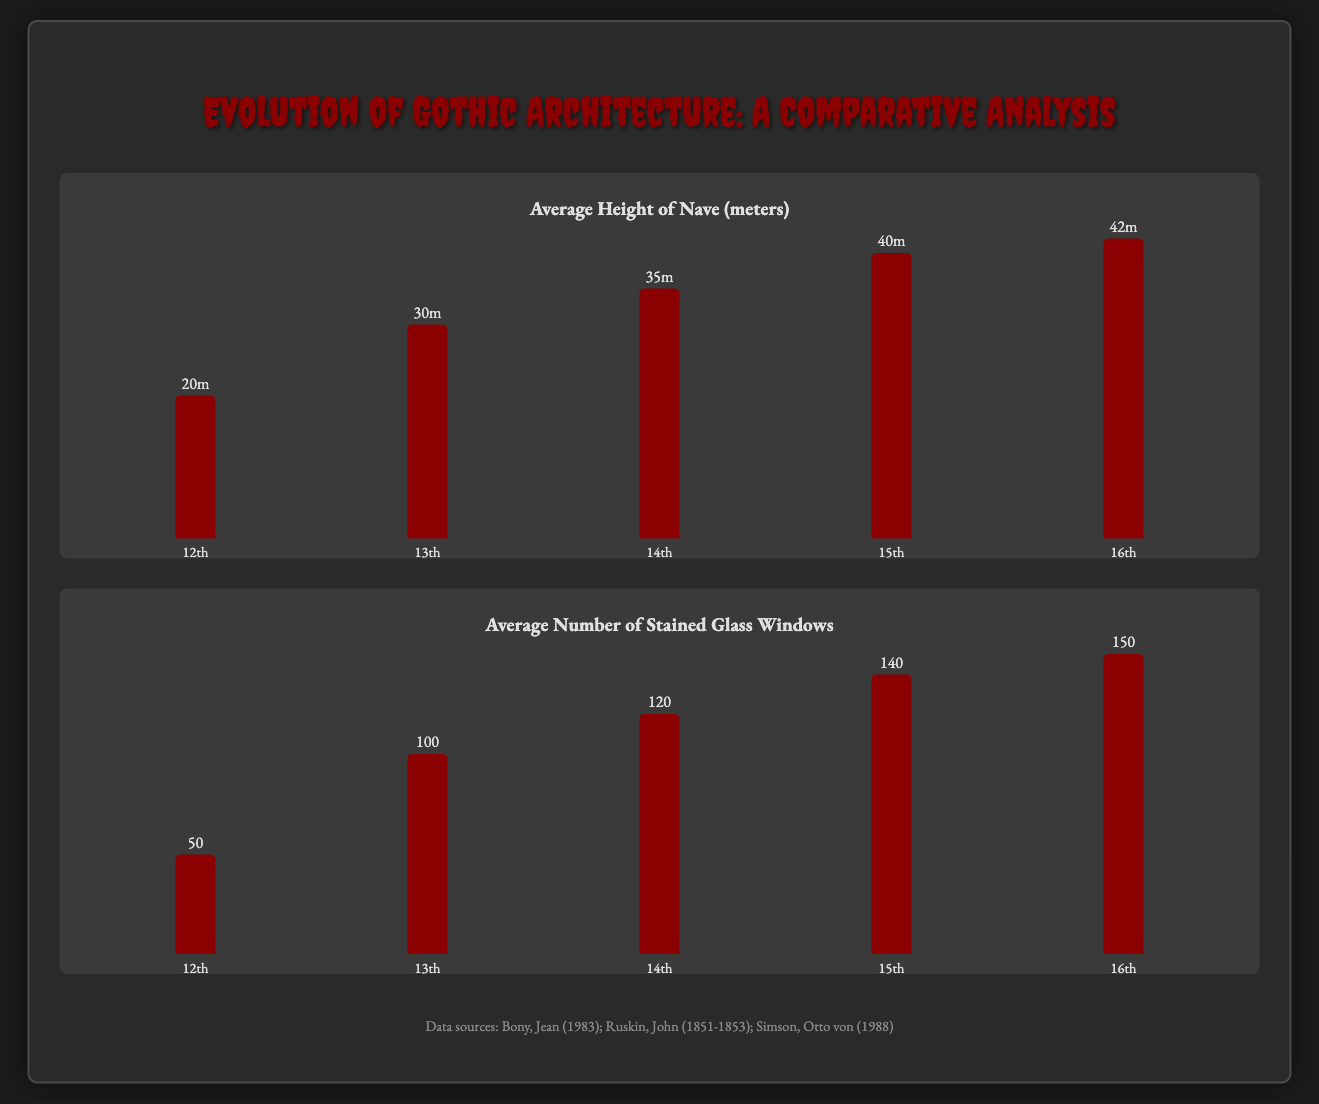what is the average height of the nave in the 14th century? The average height for the nave in the 14th century is represented by the corresponding bar on the chart, which shows 35m.
Answer: 35m how many stained glass windows were averaged in the 15th century? The average number of stained glass windows for the 15th century is indicated by the bar chart, showing 140 windows.
Answer: 140 which century had the greatest average height of the nave? The data reveals that the 16th century possesses the highest average nave height of 42m, as noted in the chart.
Answer: 16th what is the average number of stained glass windows in the 12th century? The 12th century's average number of stained glass windows is noted in the infographic as 50.
Answer: 50 which century shows an increase in the average height of the nave from the previous century? The transition from the 14th to 15th century indicates an increase in nave height from 35m to 40m.
Answer: 15th what is the percentage height representation for the 13th century nave? The percentage height representation for the nave during the 13th century is 71.4%, as depicted visually in the bar chart.
Answer: 71.4% how many stained glass windows were present in the 16th century? The infographic states that the average number of stained glass windows in the 16th century is 150.
Answer: 150 what is the height of the nave in the 12th century expressed in meters? The height of the nave in the 12th century is represented as 20m in the chart.
Answer: 20m 